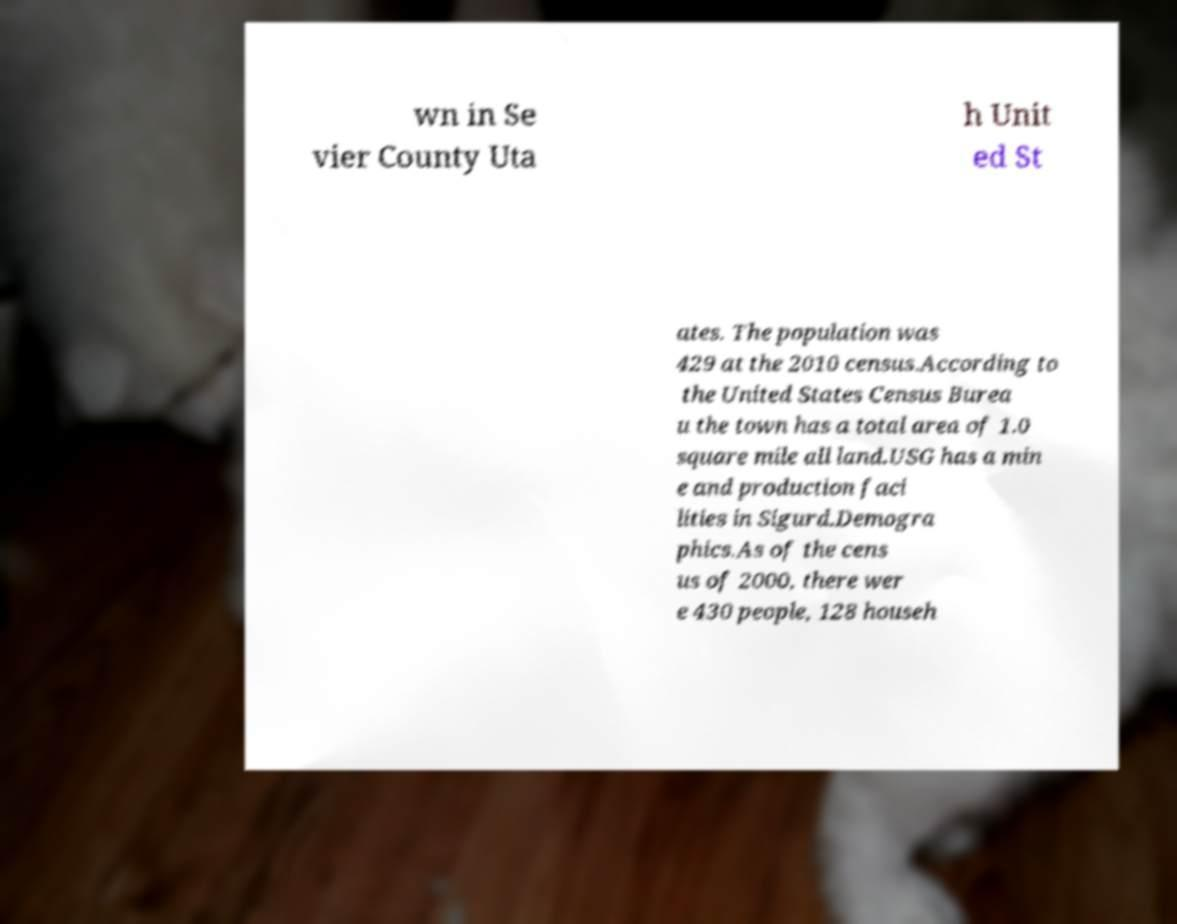There's text embedded in this image that I need extracted. Can you transcribe it verbatim? wn in Se vier County Uta h Unit ed St ates. The population was 429 at the 2010 census.According to the United States Census Burea u the town has a total area of 1.0 square mile all land.USG has a min e and production faci lities in Sigurd.Demogra phics.As of the cens us of 2000, there wer e 430 people, 128 househ 